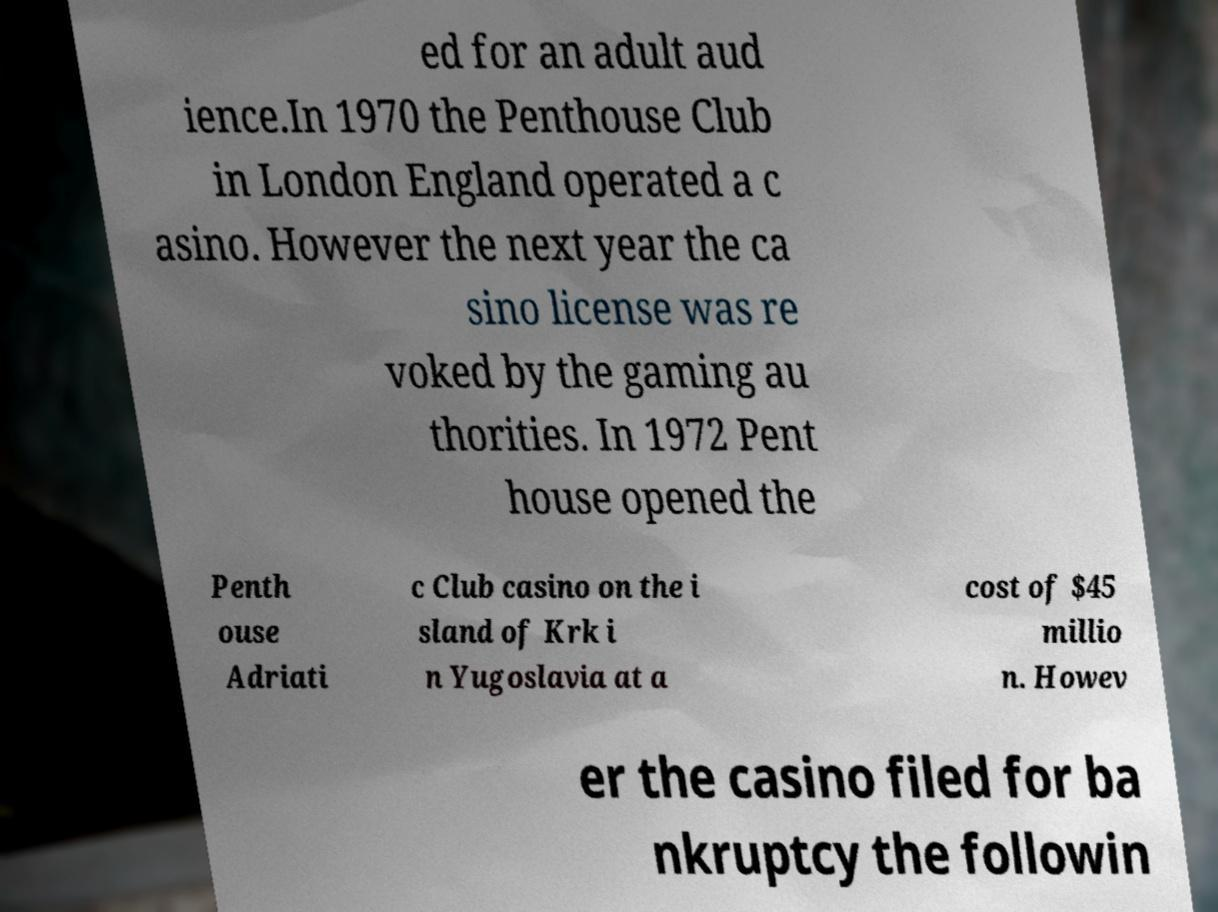Please read and relay the text visible in this image. What does it say? ed for an adult aud ience.In 1970 the Penthouse Club in London England operated a c asino. However the next year the ca sino license was re voked by the gaming au thorities. In 1972 Pent house opened the Penth ouse Adriati c Club casino on the i sland of Krk i n Yugoslavia at a cost of $45 millio n. Howev er the casino filed for ba nkruptcy the followin 